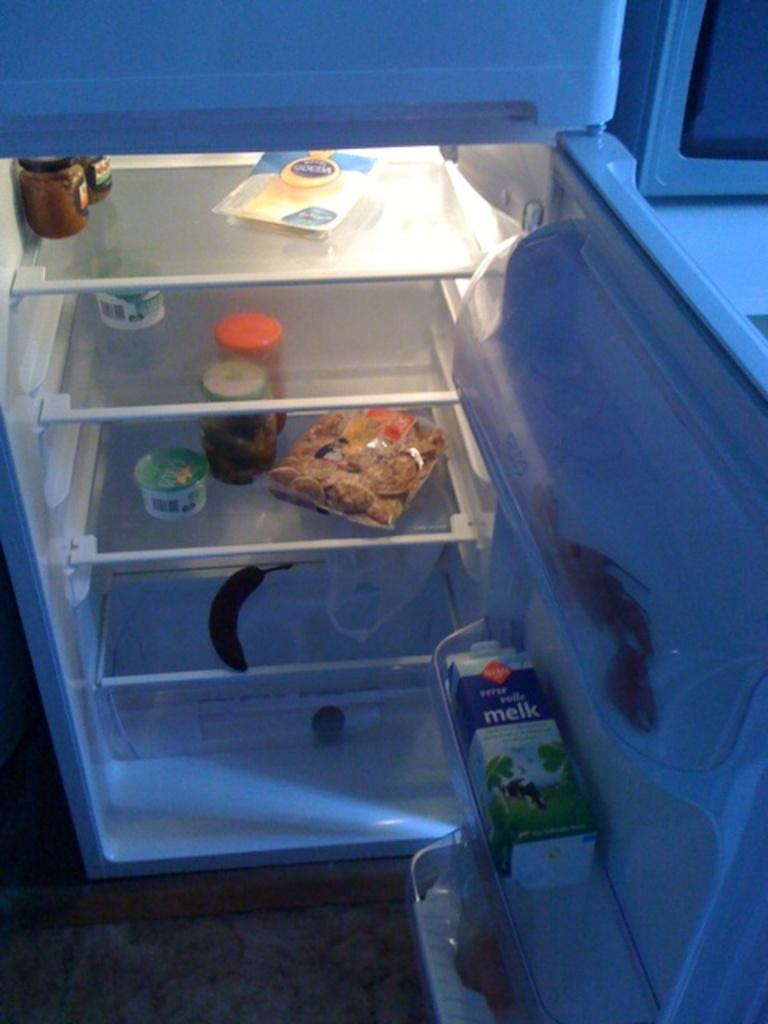<image>
Relay a brief, clear account of the picture shown. A sparse fridge has a container of "melk" on its side in the door. 